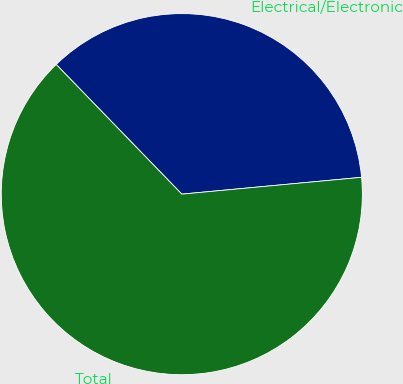Convert chart. <chart><loc_0><loc_0><loc_500><loc_500><pie_chart><fcel>Electrical/Electronic<fcel>Total<nl><fcel>35.76%<fcel>64.24%<nl></chart> 